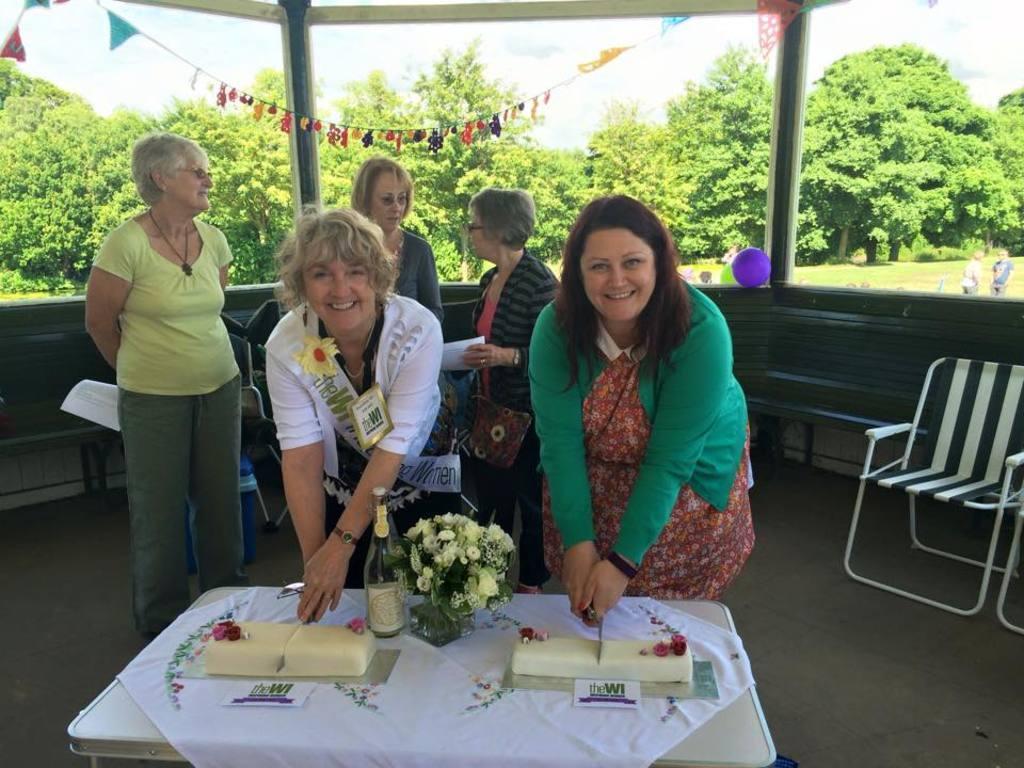Could you give a brief overview of what you see in this image? In this image there are group of women and at the foreground of the image there are two women who are cutting cake which is placed on the table and there is a flower vase on the table and at the background of the image there are trees and at the right side of the image there is a chair. 